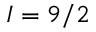Convert formula to latex. <formula><loc_0><loc_0><loc_500><loc_500>I = 9 / 2</formula> 